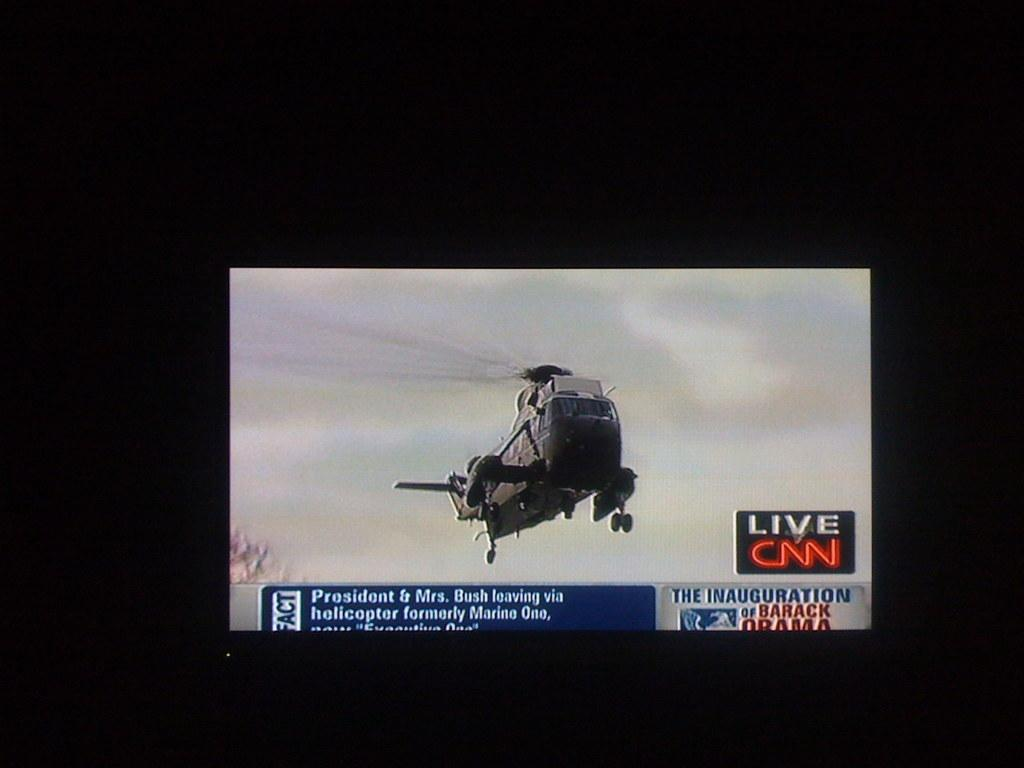What electronic device is present in the image? There is a television in the image. What is happening on the television screen? A plane is flying in the air on the television screen. Is there any text displayed on the television screen? Yes, there is text displayed below the plane on the television screen. What type of furniture is the carpenter using to fix the van in the image? There is no carpenter, van, or furniture present in the image. The image only features a television with a plane flying in the air and text displayed below it. 